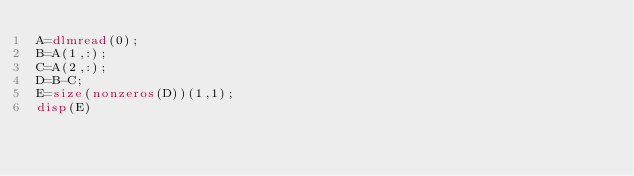<code> <loc_0><loc_0><loc_500><loc_500><_Octave_>A=dlmread(0);
B=A(1,:);
C=A(2,:);
D=B-C;
E=size(nonzeros(D))(1,1);
disp(E)
</code> 